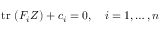Convert formula to latex. <formula><loc_0><loc_0><loc_500><loc_500>t r \ ( F _ { i } Z ) + c _ { i } = 0 , \quad i = 1 , \dots , n</formula> 